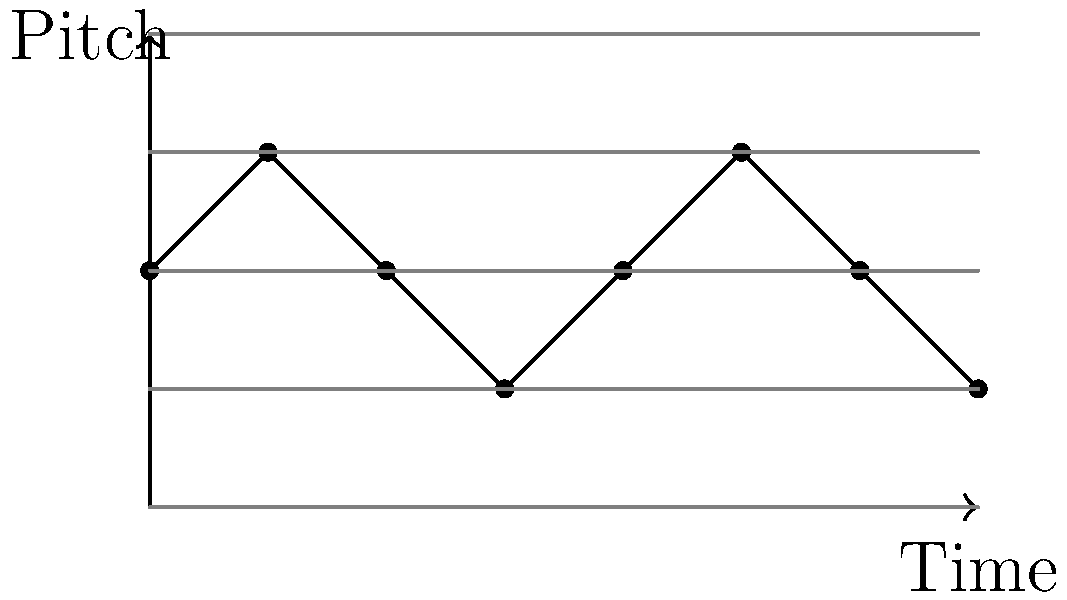As an agent representing young musicians, you're helping a client understand sheet music. The graph above represents a simple melody in treble clef. If each horizontal line represents a line or space on the staff (starting from the bottom E), what note does the highest point in the melody represent? To answer this question, let's follow these steps:

1. Understand the graph:
   - The x-axis represents time (progression of notes)
   - The y-axis represents pitch (height of notes on the staff)
   - Each horizontal line represents a line or space on the staff

2. Identify the starting point:
   - The bottom line of the graph represents the bottom line of the treble clef staff (E)

3. Count the lines and spaces:
   - There are 5 horizontal lines on the graph, representing the 5 lines of the staff
   - The spaces between these lines represent the 4 spaces of the staff

4. Determine the notes:
   - Starting from the bottom: E (line), F (space), G (line), A (space), B (line)

5. Locate the highest point:
   - The highest points in the melody reach the third line from the bottom

6. Identify the note:
   - The third line from the bottom in treble clef represents the note B

By following these steps, we can conclude that the highest note in the melody is B.
Answer: B 